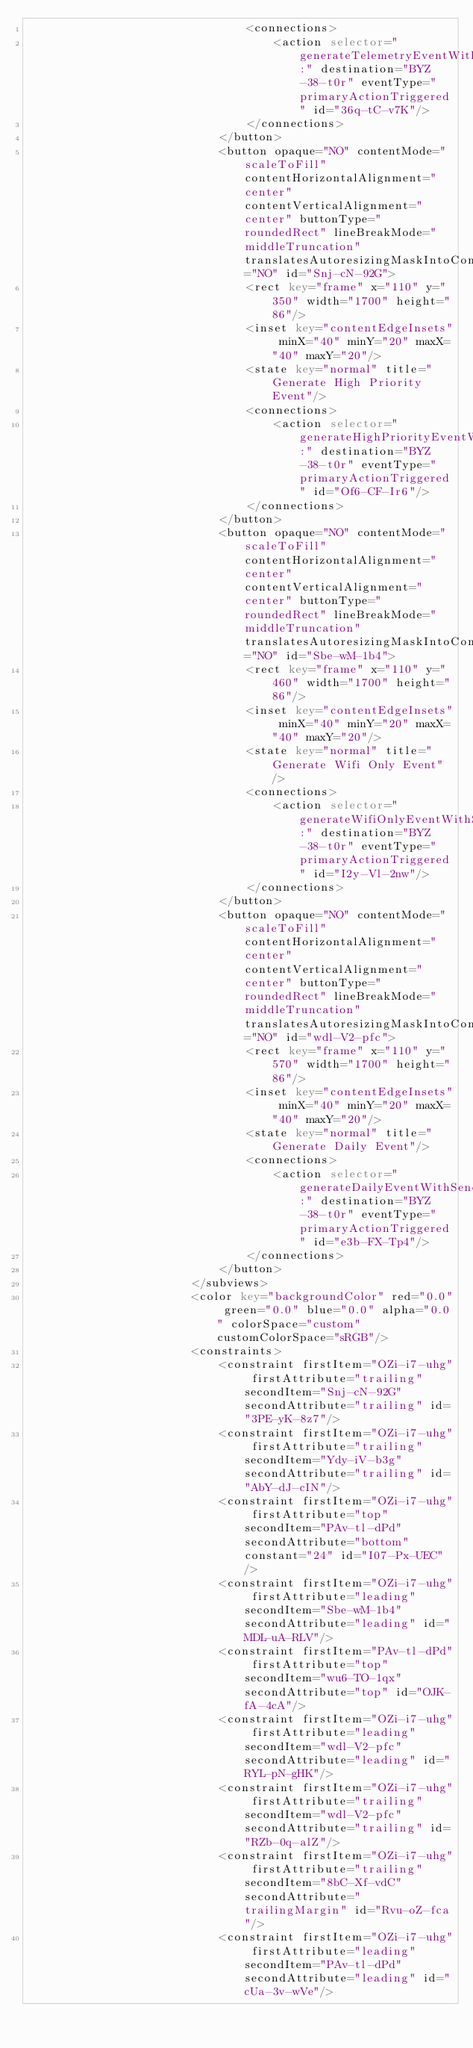<code> <loc_0><loc_0><loc_500><loc_500><_XML_>                                <connections>
                                    <action selector="generateTelemetryEventWithSender:" destination="BYZ-38-t0r" eventType="primaryActionTriggered" id="36q-tC-v7K"/>
                                </connections>
                            </button>
                            <button opaque="NO" contentMode="scaleToFill" contentHorizontalAlignment="center" contentVerticalAlignment="center" buttonType="roundedRect" lineBreakMode="middleTruncation" translatesAutoresizingMaskIntoConstraints="NO" id="Snj-cN-92G">
                                <rect key="frame" x="110" y="350" width="1700" height="86"/>
                                <inset key="contentEdgeInsets" minX="40" minY="20" maxX="40" maxY="20"/>
                                <state key="normal" title="Generate High Priority Event"/>
                                <connections>
                                    <action selector="generateHighPriorityEventWithSender:" destination="BYZ-38-t0r" eventType="primaryActionTriggered" id="Of6-CF-Ir6"/>
                                </connections>
                            </button>
                            <button opaque="NO" contentMode="scaleToFill" contentHorizontalAlignment="center" contentVerticalAlignment="center" buttonType="roundedRect" lineBreakMode="middleTruncation" translatesAutoresizingMaskIntoConstraints="NO" id="Sbe-wM-1b4">
                                <rect key="frame" x="110" y="460" width="1700" height="86"/>
                                <inset key="contentEdgeInsets" minX="40" minY="20" maxX="40" maxY="20"/>
                                <state key="normal" title="Generate Wifi Only Event"/>
                                <connections>
                                    <action selector="generateWifiOnlyEventWithSender:" destination="BYZ-38-t0r" eventType="primaryActionTriggered" id="I2y-Vl-2nw"/>
                                </connections>
                            </button>
                            <button opaque="NO" contentMode="scaleToFill" contentHorizontalAlignment="center" contentVerticalAlignment="center" buttonType="roundedRect" lineBreakMode="middleTruncation" translatesAutoresizingMaskIntoConstraints="NO" id="wdl-V2-pfc">
                                <rect key="frame" x="110" y="570" width="1700" height="86"/>
                                <inset key="contentEdgeInsets" minX="40" minY="20" maxX="40" maxY="20"/>
                                <state key="normal" title="Generate Daily Event"/>
                                <connections>
                                    <action selector="generateDailyEventWithSender:" destination="BYZ-38-t0r" eventType="primaryActionTriggered" id="e3b-FX-Tp4"/>
                                </connections>
                            </button>
                        </subviews>
                        <color key="backgroundColor" red="0.0" green="0.0" blue="0.0" alpha="0.0" colorSpace="custom" customColorSpace="sRGB"/>
                        <constraints>
                            <constraint firstItem="OZi-i7-uhg" firstAttribute="trailing" secondItem="Snj-cN-92G" secondAttribute="trailing" id="3PE-yK-8z7"/>
                            <constraint firstItem="OZi-i7-uhg" firstAttribute="trailing" secondItem="Ydy-iV-b3g" secondAttribute="trailing" id="AbY-dJ-cIN"/>
                            <constraint firstItem="OZi-i7-uhg" firstAttribute="top" secondItem="PAv-tl-dPd" secondAttribute="bottom" constant="24" id="I07-Px-UEC"/>
                            <constraint firstItem="OZi-i7-uhg" firstAttribute="leading" secondItem="Sbe-wM-1b4" secondAttribute="leading" id="MDL-uA-RLV"/>
                            <constraint firstItem="PAv-tl-dPd" firstAttribute="top" secondItem="wu6-TO-1qx" secondAttribute="top" id="OJK-fA-4cA"/>
                            <constraint firstItem="OZi-i7-uhg" firstAttribute="leading" secondItem="wdl-V2-pfc" secondAttribute="leading" id="RYL-pN-gHK"/>
                            <constraint firstItem="OZi-i7-uhg" firstAttribute="trailing" secondItem="wdl-V2-pfc" secondAttribute="trailing" id="RZb-0q-alZ"/>
                            <constraint firstItem="OZi-i7-uhg" firstAttribute="trailing" secondItem="8bC-Xf-vdC" secondAttribute="trailingMargin" id="Rvu-oZ-fca"/>
                            <constraint firstItem="OZi-i7-uhg" firstAttribute="leading" secondItem="PAv-tl-dPd" secondAttribute="leading" id="cUa-3v-wVe"/></code> 